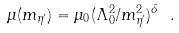<formula> <loc_0><loc_0><loc_500><loc_500>\mu ( m _ { \eta ^ { \prime } } ) = \mu _ { 0 } ( \Lambda _ { 0 } ^ { 2 } / m _ { \eta ^ { \prime } } ^ { 2 } ) ^ { \delta } \ .</formula> 